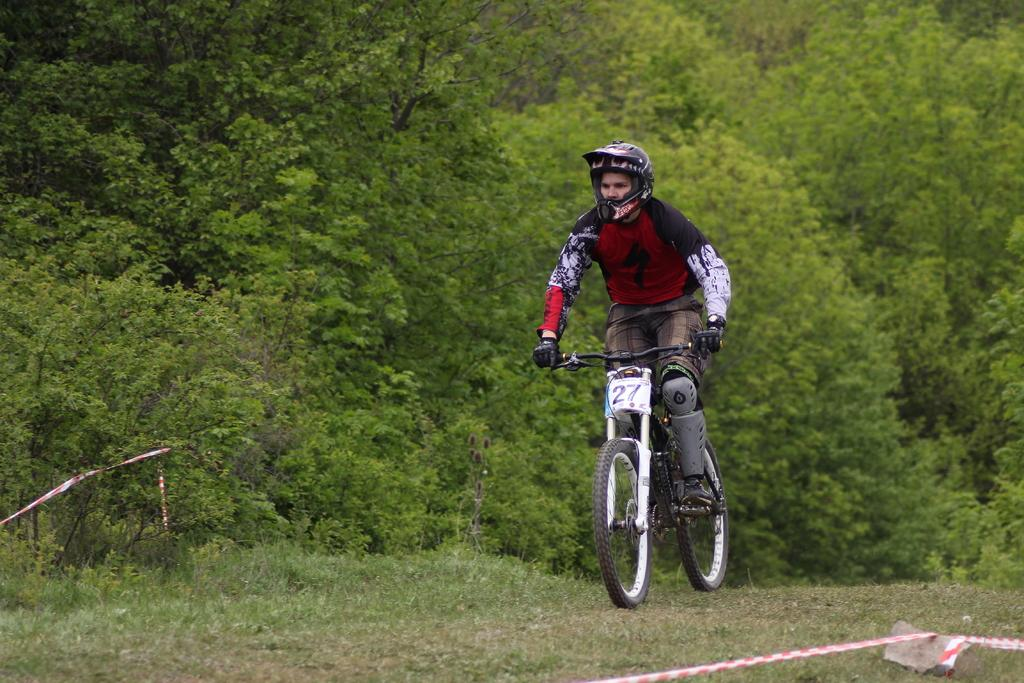What is the man in the image doing? The man is riding a bicycle in the image. Where is the man located in the image? The man is on the ground. What can be seen in the background of the image? There is a group of trees in the background of the image. What other objects are visible in the image? There is a stone and a ribbon visible in the image. What type of flame can be seen coming from the bicycle in the image? There is no flame present in the image; the man is simply riding a bicycle. 